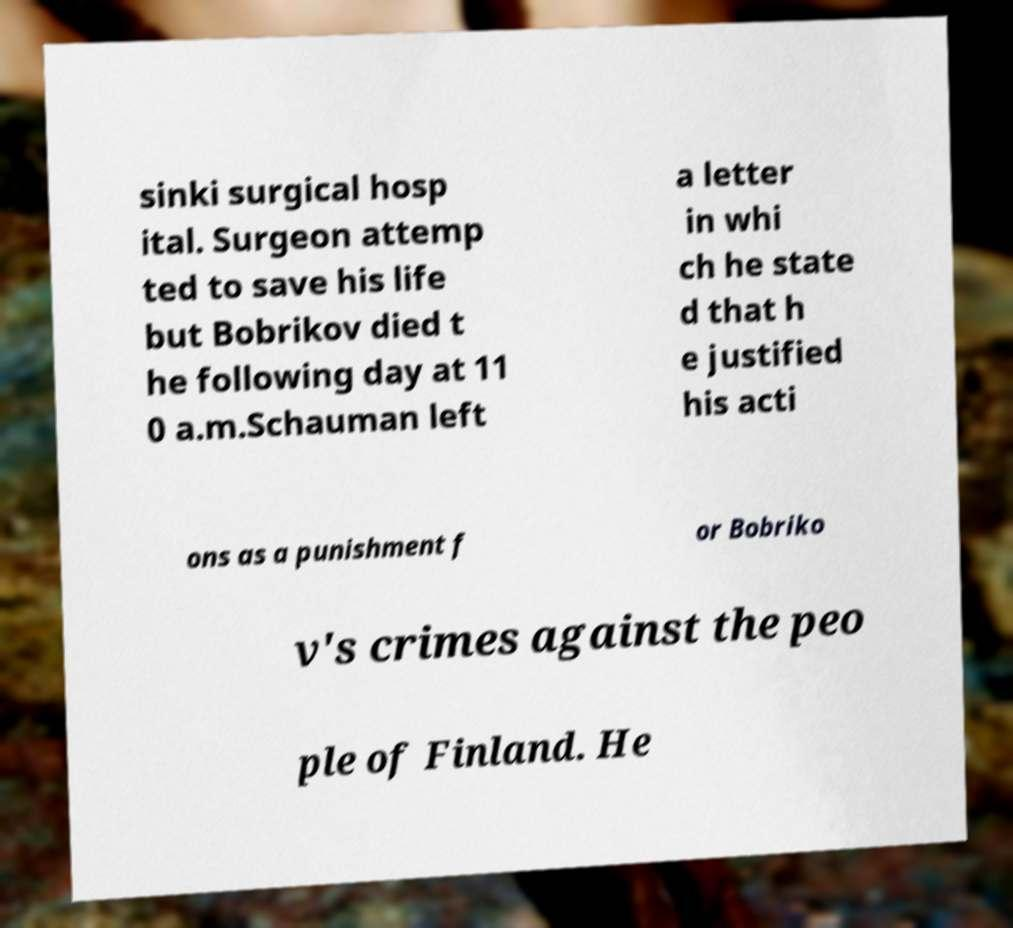Could you assist in decoding the text presented in this image and type it out clearly? sinki surgical hosp ital. Surgeon attemp ted to save his life but Bobrikov died t he following day at 11 0 a.m.Schauman left a letter in whi ch he state d that h e justified his acti ons as a punishment f or Bobriko v's crimes against the peo ple of Finland. He 